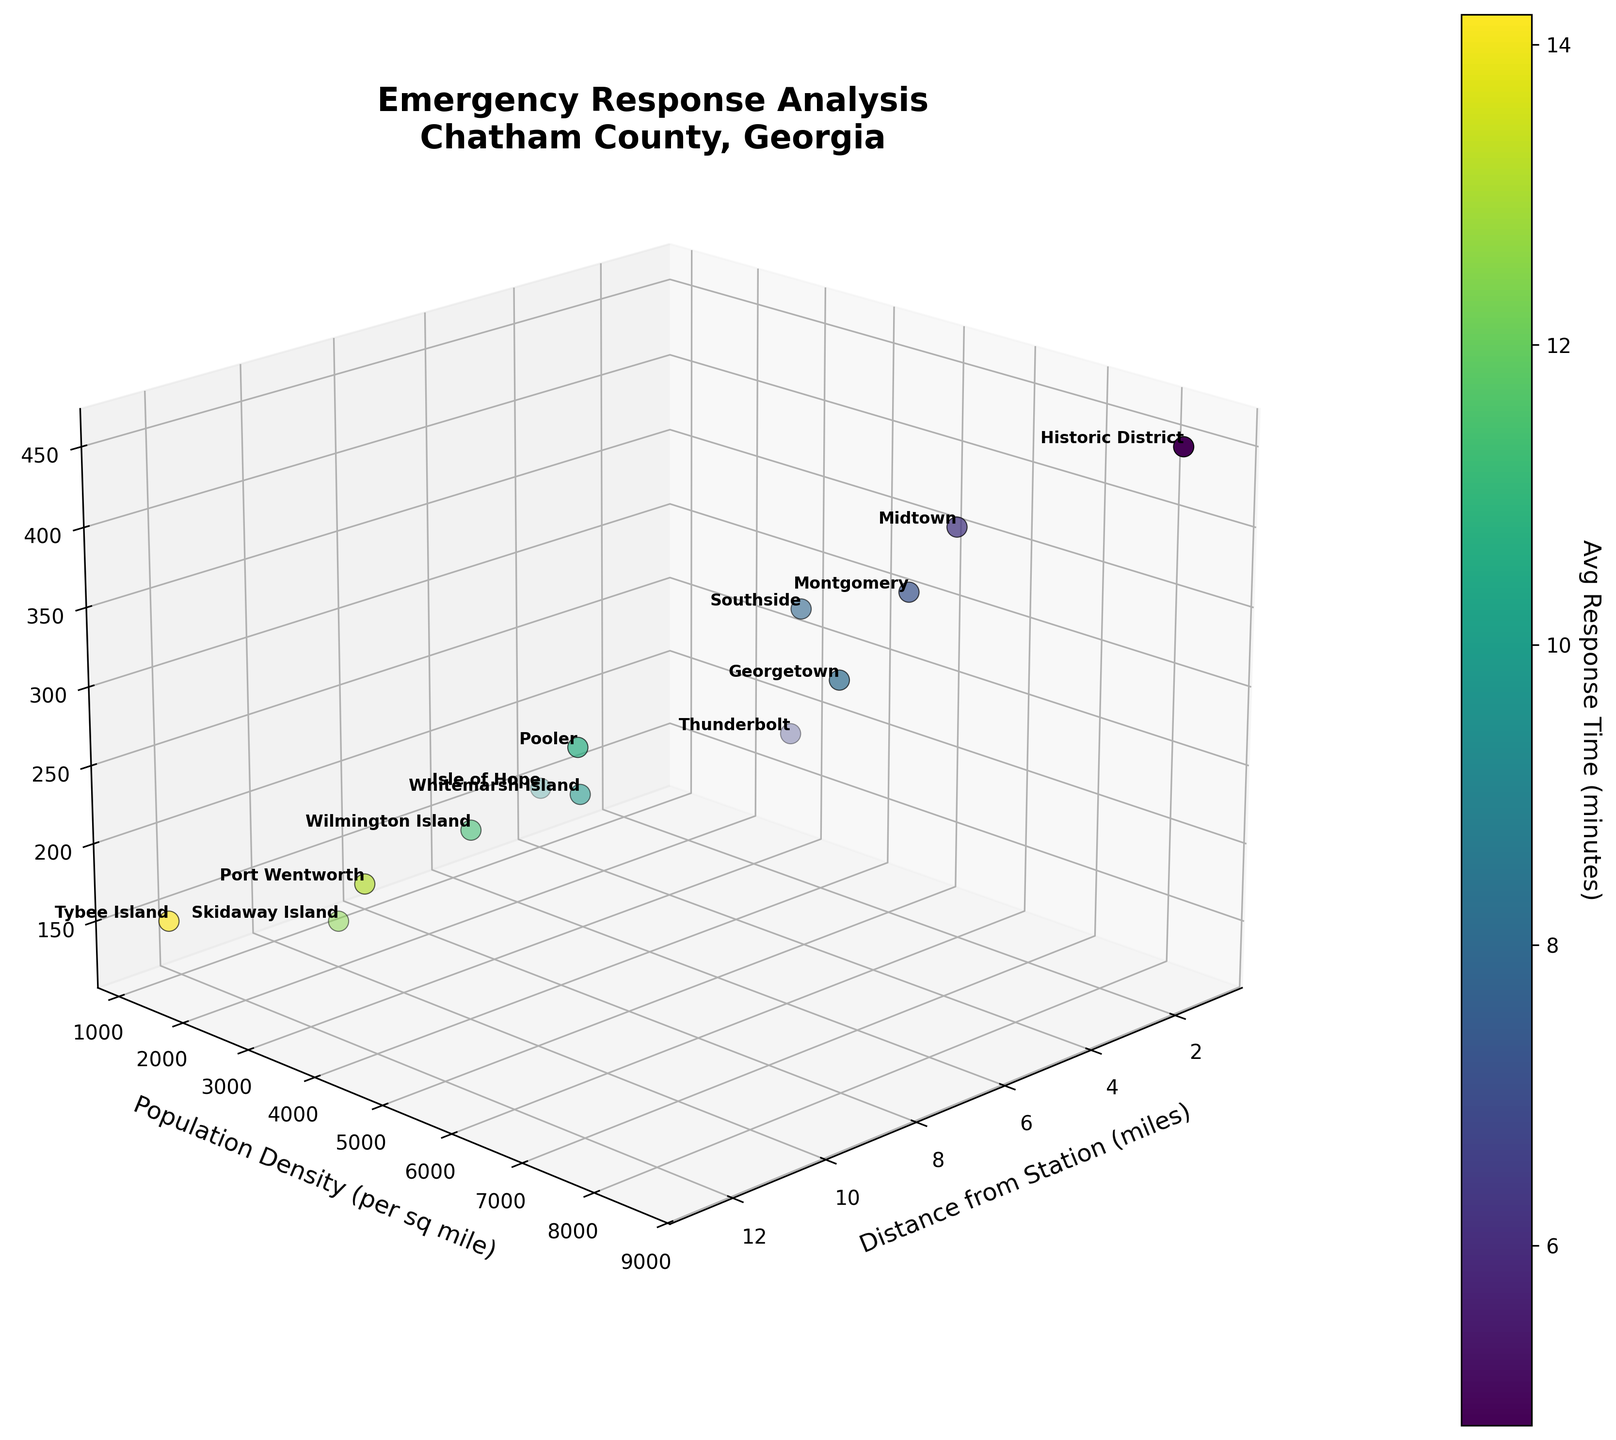What is the title of the plot? The title is displayed at the top center of the plot, reading "Emergency Response Analysis\nChatham County, Georgia".
Answer: Emergency Response Analysis\nChatham County, Georgia How many neighborhoods are represented in the plot? By counting the labels of the points in the plot, we see there are 13 neighborhoods.
Answer: 13 Which neighborhood has the highest population density? By inspecting the y-axis, the neighborhood with the highest value is the Historic District, with a population density of 8500 per sq mile.
Answer: Historic District What is the average response time for Thunderbolt? Locate Thunderbolt on the plot and check the color legend which indicates the Avg Response Time. The color indicates an average response time of about 6.7 minutes.
Answer: 6.7 minutes Which neighborhood is furthest from the emergency station? By observing the x-axis, Tybee Island is the furthest with a distance of 12.5 miles.
Answer: Tybee Island Does higher population density correlate with higher incident frequency? By looking at the y-axis (Population Density) and z-axis (Incident Frequency), we observe that neighborhoods with higher population densities, like Historic District and Midtown, also have higher incident frequencies, suggesting a positive correlation.
Answer: Yes Compare the average response times for Southside and Pooler. Which is longer? Southside and Pooler can be located on the plot; Pooler has a color indicating a higher response time. Pooler’s response time is about 10.7 minutes, while Southside’s is about 7.9 minutes.
Answer: Pooler Which neighborhood has the lowest incident frequency? Checking the z-axis, Skidaway Island has the lowest incident frequency, with an annual incident frequency of 130.
Answer: Skidaway Island What neighborhood is closest to the station and has a population density below 3000 per sq mile? From the plot, the closest neighborhoods (x-axis) need population density (y-axis) below 3000. Thunderbolt matches these criteria being 2.9 miles away with a population density of 4100 per sq mile. However, if we use sq mile strictly under 3000 per sq mile, Whitemarsh Island would be closer with 3500 population density.
Answer: Whitemarsh Island Is there a general trend in response time with increasing distance from the station? Observing the color gradient and x-axis (Distance from Station), neighborhoods further tend to have colors representing longer response times, indicating longer response times with increased distance.
Answer: Yes 